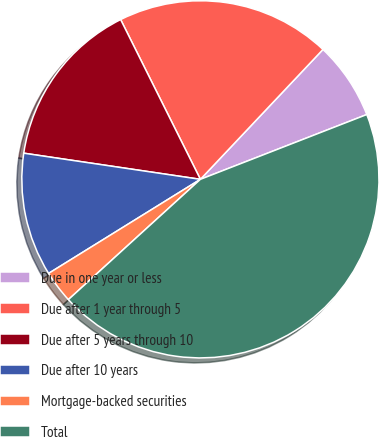<chart> <loc_0><loc_0><loc_500><loc_500><pie_chart><fcel>Due in one year or less<fcel>Due after 1 year through 5<fcel>Due after 5 years through 10<fcel>Due after 10 years<fcel>Mortgage-backed securities<fcel>Total<nl><fcel>7.05%<fcel>19.41%<fcel>15.29%<fcel>11.17%<fcel>2.93%<fcel>44.15%<nl></chart> 